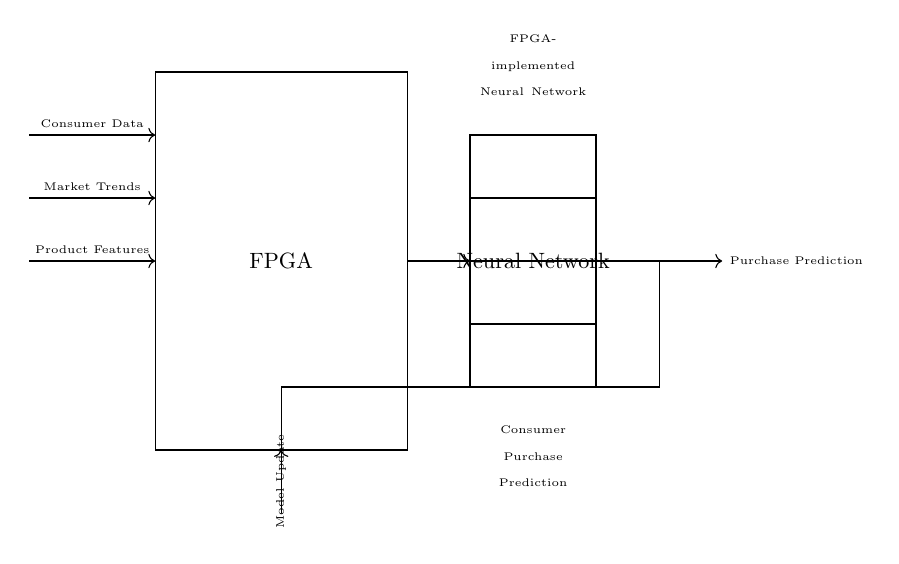What is the primary component in this circuit? The primary component is the FPGA, which stands for Field-Programmable Gate Array, serving as the main processing unit in the design.
Answer: FPGA What type of network is represented in this circuit? The circuit represents a Neural Network, which is configured to process and analyze data for making predictions.
Answer: Neural Network What are the inputs to the neural network? The inputs are Consumer Data, Market Trends, and Product Features, which feed relevant information into the network for analysis.
Answer: Consumer Data, Market Trends, Product Features What is the output of this neural network? The output is Purchase Prediction, which indicates the expected consumer purchasing behavior based on the analysis performed by the neural network.
Answer: Purchase Prediction What function does the feedback loop serve in this circuit? The feedback loop is used for Model Update, enabling the neural network to refine its predictions based on the outcomes and improve its learning over time.
Answer: Model Update How many layers are shown in the neural network? There are three layers represented in the neural network, as indicated by the three distinct horizontal lines within the rectangular block representing the neural network.
Answer: Three 